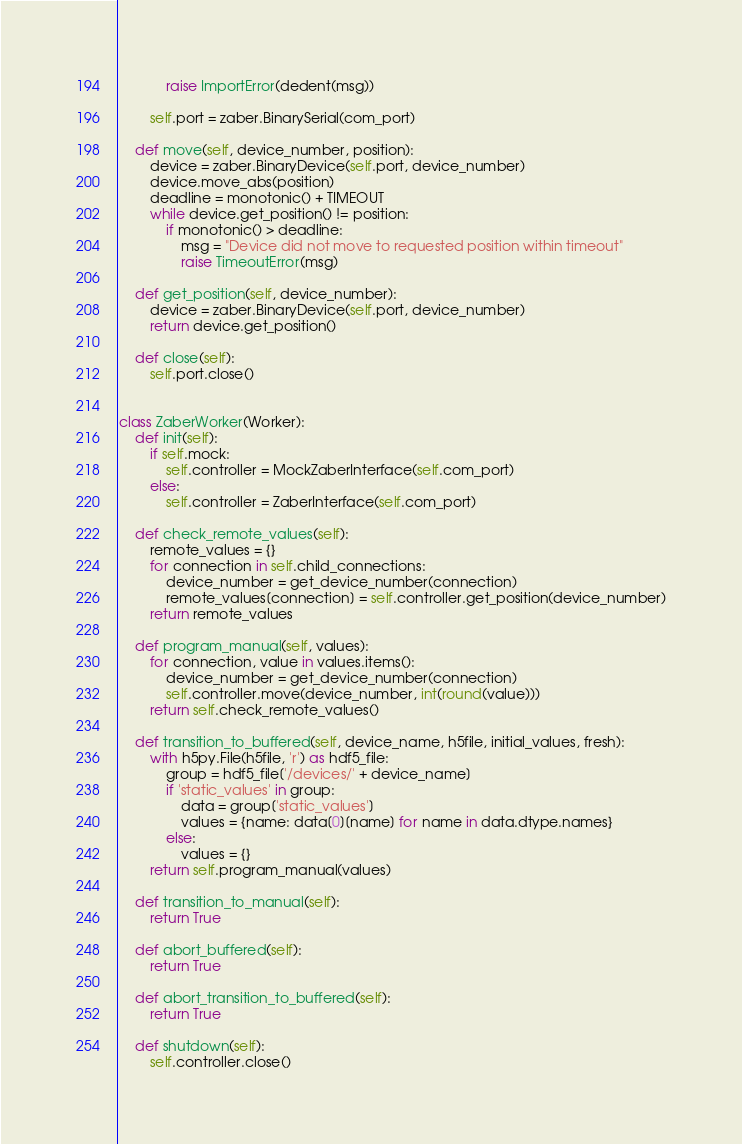<code> <loc_0><loc_0><loc_500><loc_500><_Python_>            raise ImportError(dedent(msg))

        self.port = zaber.BinarySerial(com_port)

    def move(self, device_number, position):
        device = zaber.BinaryDevice(self.port, device_number)
        device.move_abs(position)
        deadline = monotonic() + TIMEOUT
        while device.get_position() != position:
            if monotonic() > deadline:
                msg = "Device did not move to requested position within timeout"
                raise TimeoutError(msg)

    def get_position(self, device_number):
        device = zaber.BinaryDevice(self.port, device_number)
        return device.get_position()

    def close(self):
        self.port.close()


class ZaberWorker(Worker):
    def init(self):
        if self.mock:
            self.controller = MockZaberInterface(self.com_port)
        else:
            self.controller = ZaberInterface(self.com_port)

    def check_remote_values(self):
        remote_values = {} 
        for connection in self.child_connections:
            device_number = get_device_number(connection)
            remote_values[connection] = self.controller.get_position(device_number)
        return remote_values

    def program_manual(self, values):
        for connection, value in values.items():
            device_number = get_device_number(connection)
            self.controller.move(device_number, int(round(value)))
        return self.check_remote_values()

    def transition_to_buffered(self, device_name, h5file, initial_values, fresh):
        with h5py.File(h5file, 'r') as hdf5_file:
            group = hdf5_file['/devices/' + device_name]
            if 'static_values' in group:
                data = group['static_values']
                values = {name: data[0][name] for name in data.dtype.names}
            else:
                values = {}
        return self.program_manual(values)

    def transition_to_manual(self):
        return True

    def abort_buffered(self):
        return True

    def abort_transition_to_buffered(self):
        return True

    def shutdown(self):
        self.controller.close()
</code> 